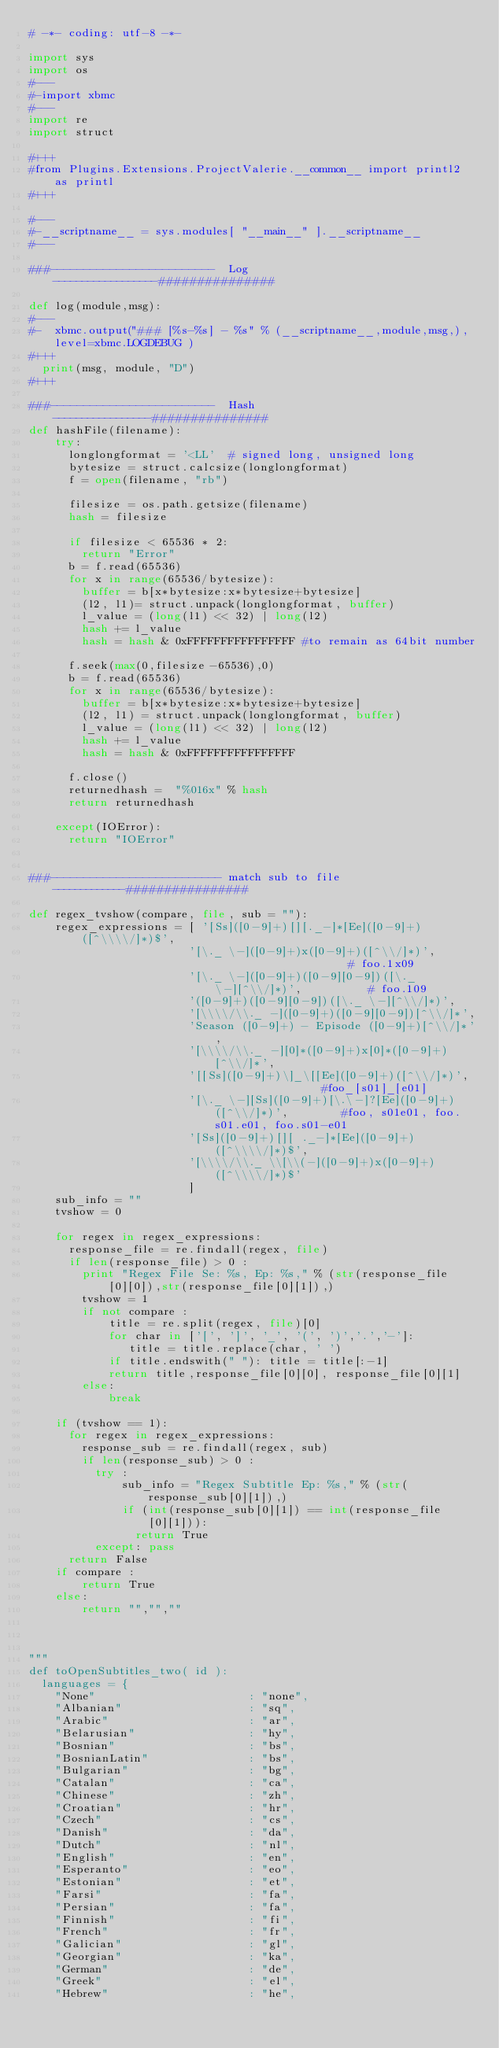<code> <loc_0><loc_0><loc_500><loc_500><_Python_># -*- coding: utf-8 -*- 

import sys
import os
#---
#-import xbmc
#---
import re
import struct

#+++
#from Plugins.Extensions.ProjectValerie.__common__ import printl2 as printl
#+++

#---
#-__scriptname__ = sys.modules[ "__main__" ].__scriptname__
#---

###-------------------------  Log  ------------------###############
   
def log(module,msg):
#---
#-  xbmc.output("### [%s-%s] - %s" % (__scriptname__,module,msg,),level=xbmc.LOGDEBUG )
#+++
  print(msg, module, "D")
#+++ 

###-------------------------  Hash  -----------------###############
def hashFile(filename): 
    try: 
      longlongformat = '<LL'  # signed long, unsigned long 
      bytesize = struct.calcsize(longlongformat) 
      f = open(filename, "rb") 
          
      filesize = os.path.getsize(filename)
      hash = filesize 
          
      if filesize < 65536 * 2:
        return "Error"
      b = f.read(65536)
      for x in range(65536/bytesize):
        buffer = b[x*bytesize:x*bytesize+bytesize]
        (l2, l1)= struct.unpack(longlongformat, buffer) 
        l_value = (long(l1) << 32) | long(l2) 
        hash += l_value 
        hash = hash & 0xFFFFFFFFFFFFFFFF #to remain as 64bit number
      
      f.seek(max(0,filesize-65536),0)
      b = f.read(65536)
      for x in range(65536/bytesize):
        buffer = b[x*bytesize:x*bytesize+bytesize]
        (l2, l1) = struct.unpack(longlongformat, buffer)
        l_value = (long(l1) << 32) | long(l2)
        hash += l_value
        hash = hash & 0xFFFFFFFFFFFFFFFF
      
      f.close() 
      returnedhash =  "%016x" % hash 
      return returnedhash
    
    except(IOError): 
      return "IOError"


###-------------------------- match sub to file  -------------################        

def regex_tvshow(compare, file, sub = ""):
    regex_expressions = [ '[Ss]([0-9]+)[][._-]*[Ee]([0-9]+)([^\\\\/]*)$',
                        '[\._ \-]([0-9]+)x([0-9]+)([^\\/]*)',                     # foo.1x09 
                        '[\._ \-]([0-9]+)([0-9][0-9])([\._ \-][^\\/]*)',          # foo.109
                        '([0-9]+)([0-9][0-9])([\._ \-][^\\/]*)',
                        '[\\\\/\\._ -]([0-9]+)([0-9][0-9])[^\\/]*',
                        'Season ([0-9]+) - Episode ([0-9]+)[^\\/]*',
                        '[\\\\/\\._ -][0]*([0-9]+)x[0]*([0-9]+)[^\\/]*',
                        '[[Ss]([0-9]+)\]_\[[Ee]([0-9]+)([^\\/]*)',                 #foo_[s01]_[e01]
                        '[\._ \-][Ss]([0-9]+)[\.\-]?[Ee]([0-9]+)([^\\/]*)',        #foo, s01e01, foo.s01.e01, foo.s01-e01
                        '[Ss]([0-9]+)[][ ._-]*[Ee]([0-9]+)([^\\\\/]*)$',
                        '[\\\\/\\._ \\[\\(-]([0-9]+)x([0-9]+)([^\\\\/]*)$'
                        ]
    sub_info = ""
    tvshow = 0
    
    for regex in regex_expressions:
      response_file = re.findall(regex, file)                  
      if len(response_file) > 0 : 
        print "Regex File Se: %s, Ep: %s," % (str(response_file[0][0]),str(response_file[0][1]),)
        tvshow = 1
        if not compare :
            title = re.split(regex, file)[0]
            for char in ['[', ']', '_', '(', ')','.','-']: 
               title = title.replace(char, ' ')
            if title.endswith(" "): title = title[:-1]
            return title,response_file[0][0], response_file[0][1]
        else:
            break
    
    if (tvshow == 1):
      for regex in regex_expressions:       
        response_sub = re.findall(regex, sub)
        if len(response_sub) > 0 :
          try :
              sub_info = "Regex Subtitle Ep: %s," % (str(response_sub[0][1]),)
              if (int(response_sub[0][1]) == int(response_file[0][1])):
                return True
          except: pass      
      return False
    if compare :
        return True
    else:
        return "","",""    



"""
def toOpenSubtitles_two( id ):
  languages = { 
  	"None"                       : "none",
    "Albanian"                   : "sq",
    "Arabic"                     : "ar",
    "Belarusian"                 : "hy",
    "Bosnian"                    : "bs",
    "BosnianLatin"               : "bs",
    "Bulgarian"                  : "bg",
    "Catalan"                    : "ca",
    "Chinese"                    : "zh",
    "Croatian"                   : "hr",
    "Czech"                      : "cs",
    "Danish"                     : "da",
    "Dutch"                      : "nl",
    "English"                    : "en",
    "Esperanto"                  : "eo",
    "Estonian"                   : "et",
    "Farsi"                      : "fa",
    "Persian"                    : "fa",
    "Finnish"                    : "fi",
    "French"                     : "fr",
    "Galician"                   : "gl",
    "Georgian"                   : "ka",
    "German"                     : "de",
    "Greek"                      : "el",
    "Hebrew"                     : "he",</code> 